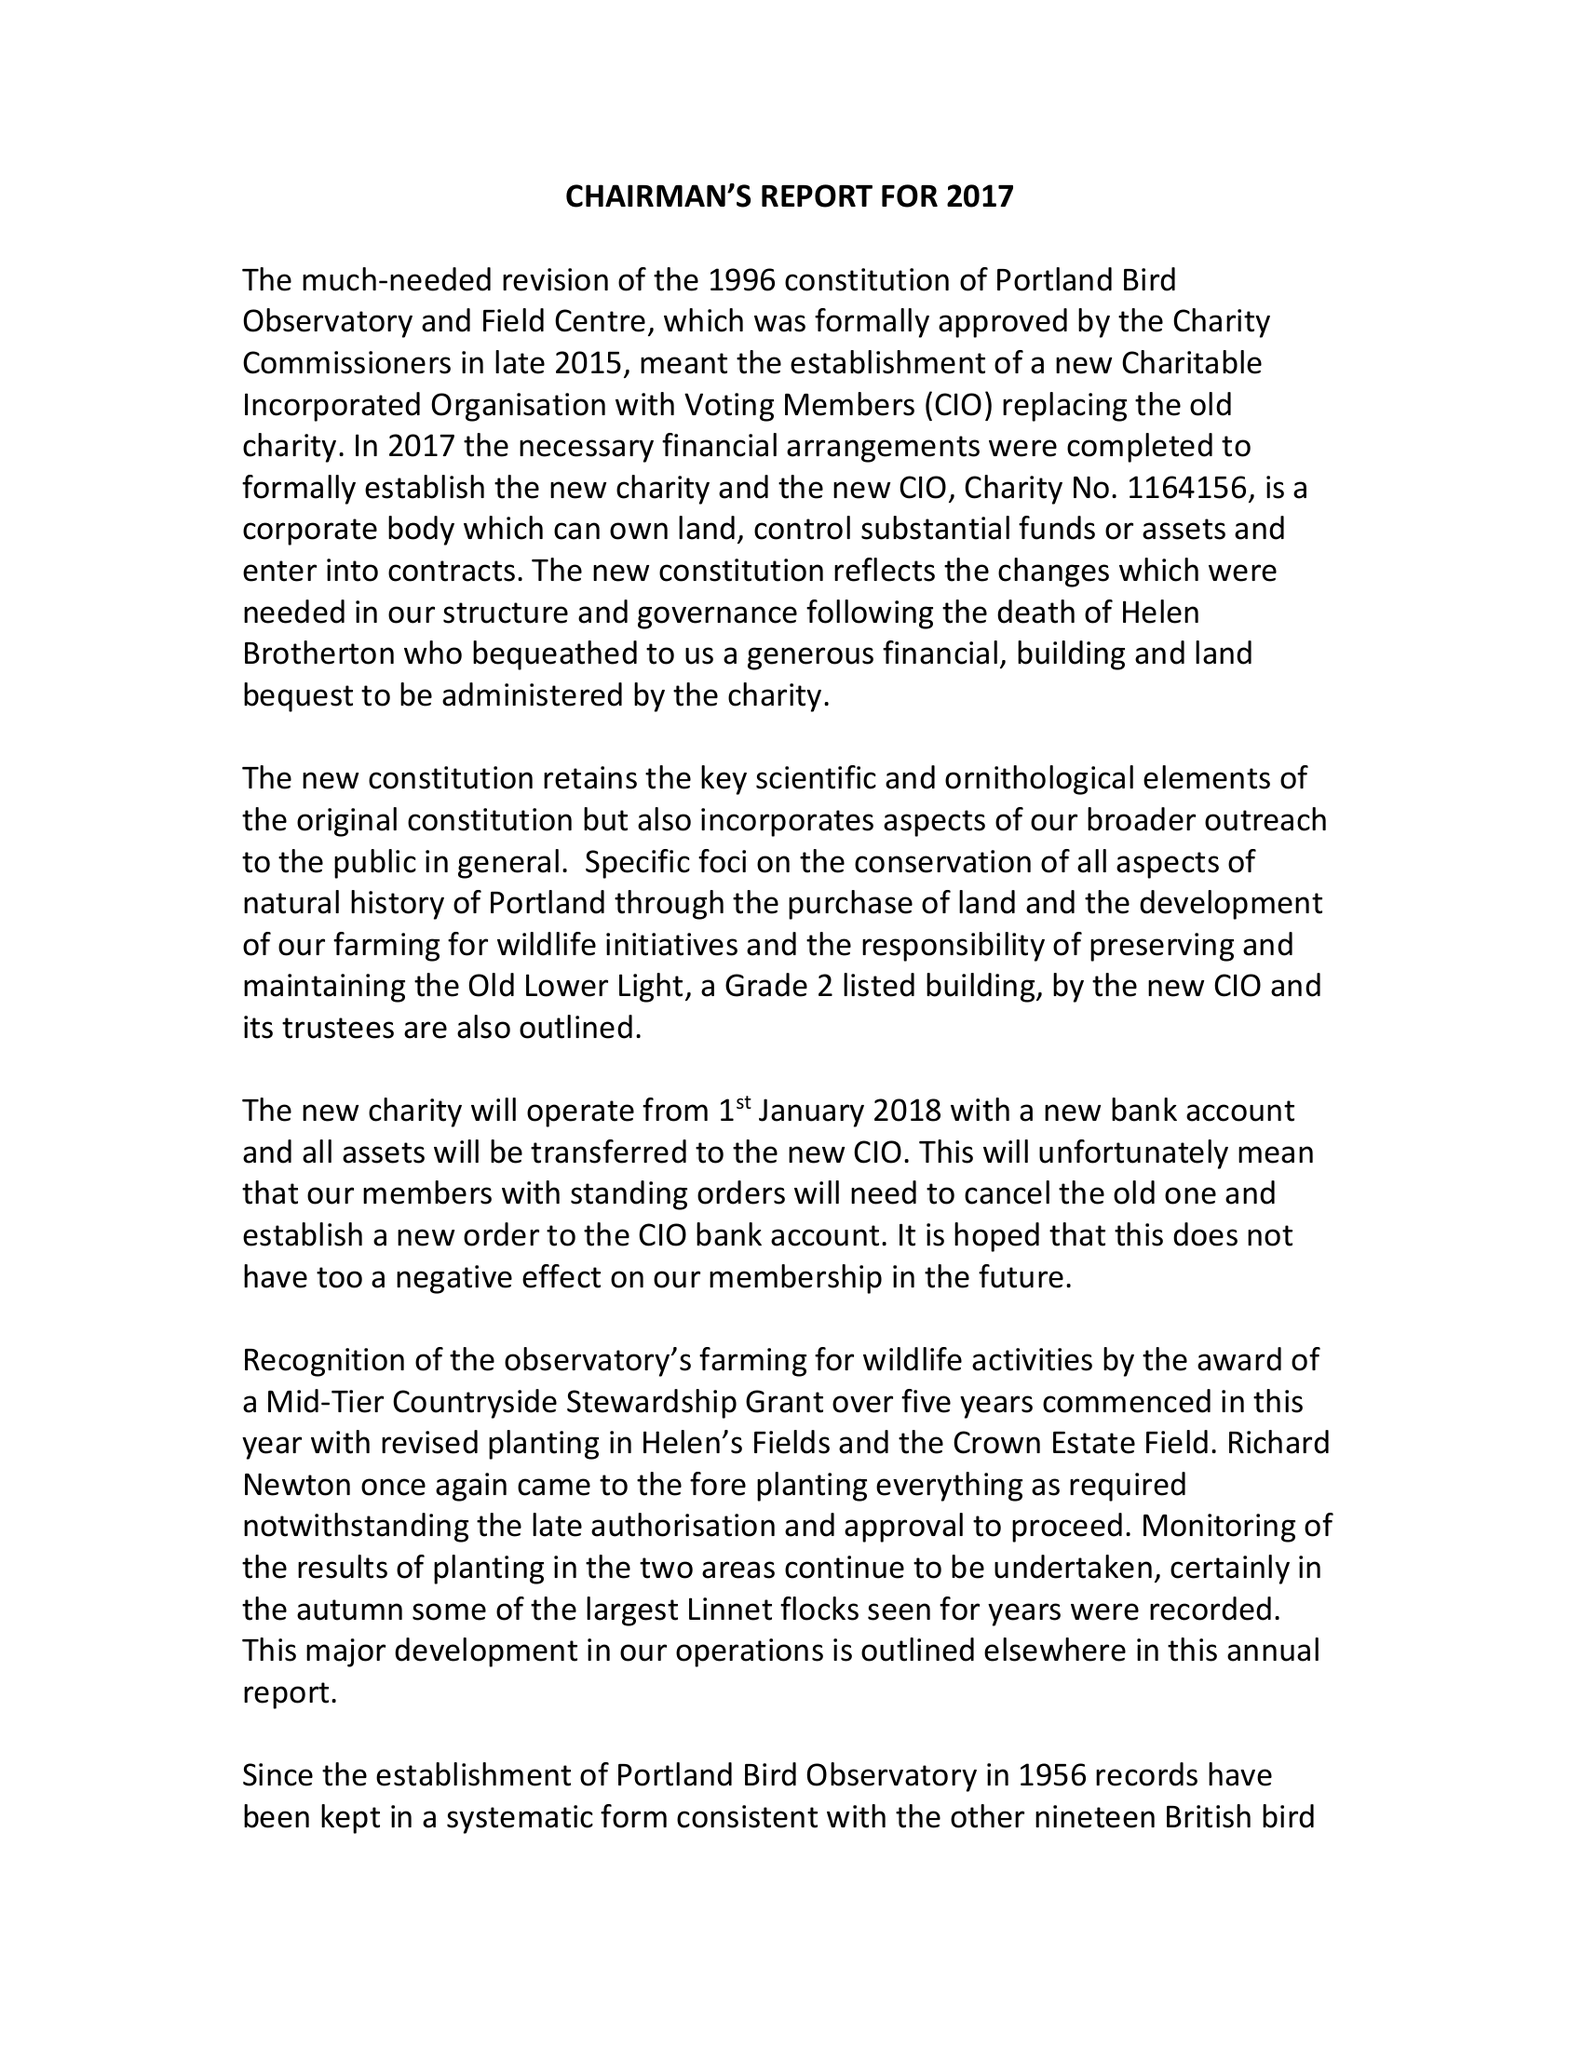What is the value for the address__post_town?
Answer the question using a single word or phrase. PORTLAND 